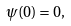Convert formula to latex. <formula><loc_0><loc_0><loc_500><loc_500>\psi ( 0 ) = 0 ,</formula> 